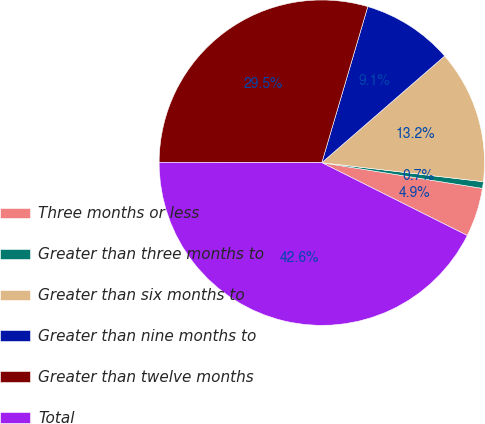Convert chart. <chart><loc_0><loc_0><loc_500><loc_500><pie_chart><fcel>Three months or less<fcel>Greater than three months to<fcel>Greater than six months to<fcel>Greater than nine months to<fcel>Greater than twelve months<fcel>Total<nl><fcel>4.86%<fcel>0.66%<fcel>13.25%<fcel>9.06%<fcel>29.53%<fcel>42.65%<nl></chart> 